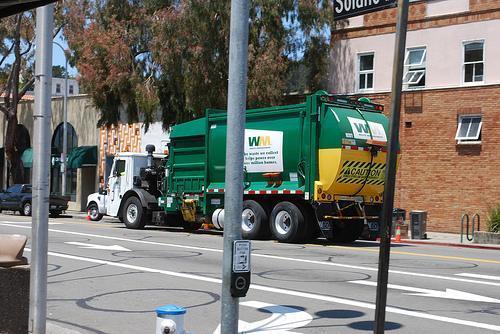How many trucks are there?
Give a very brief answer. 1. 